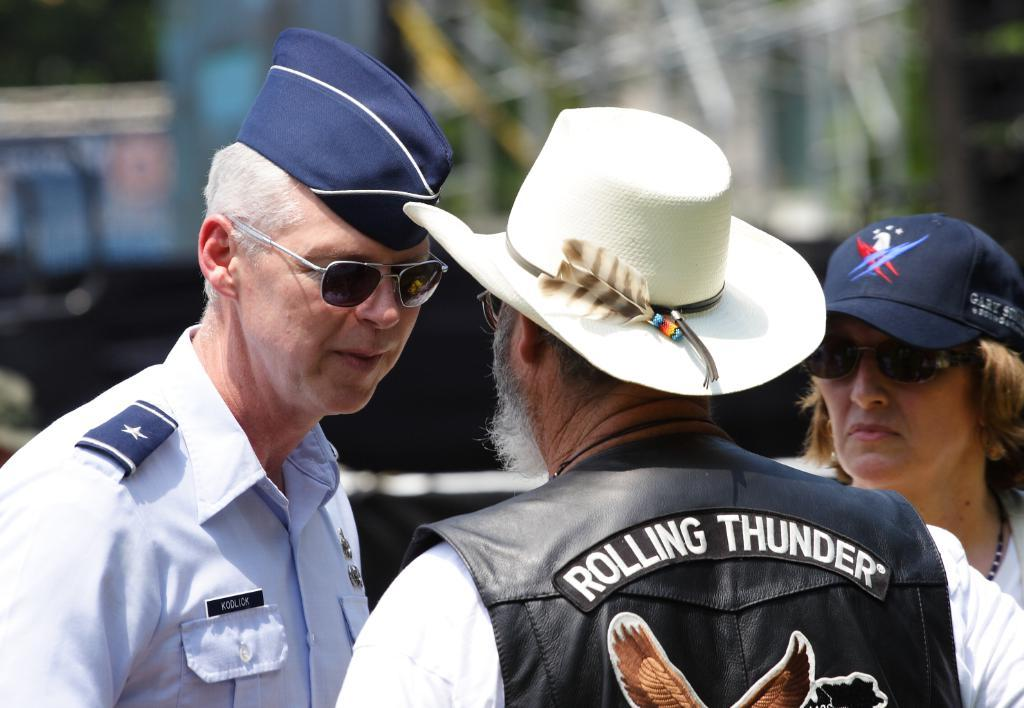How many people are in the image? There are two men and a woman in the image. What are the individuals wearing? The individuals are wearing clothes. Are any of the individuals wearing a cap? Yes, one or more individuals are wearing a cap. Are any of the individuals wearing goggles? Yes, one or more individuals are wearing goggles. What type of accessory is visible in the image? There is a neck chain visible in the image. Can you describe the background of the image? The background of the image is blurred. What type of clam can be seen playing in the alley in the image? There is no clam or alley present in the image; it features two men, a woman, and a blurred background. What type of game are the individuals playing in the image? There is no indication of a game being played in the image; the individuals are simply standing or wearing specific items. 